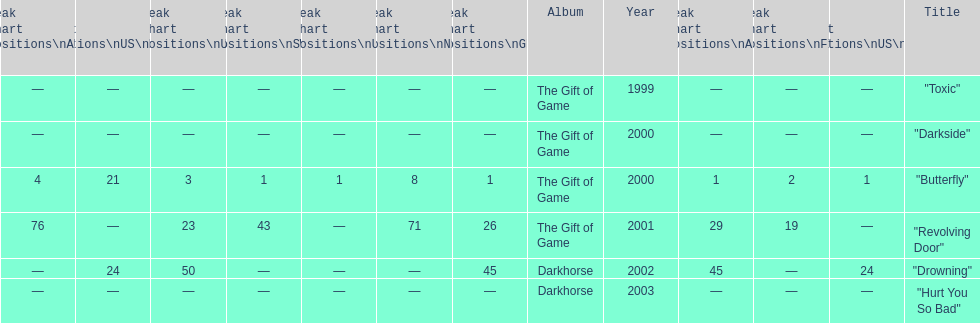How many singles have a ranking of 1 under ger? 1. 